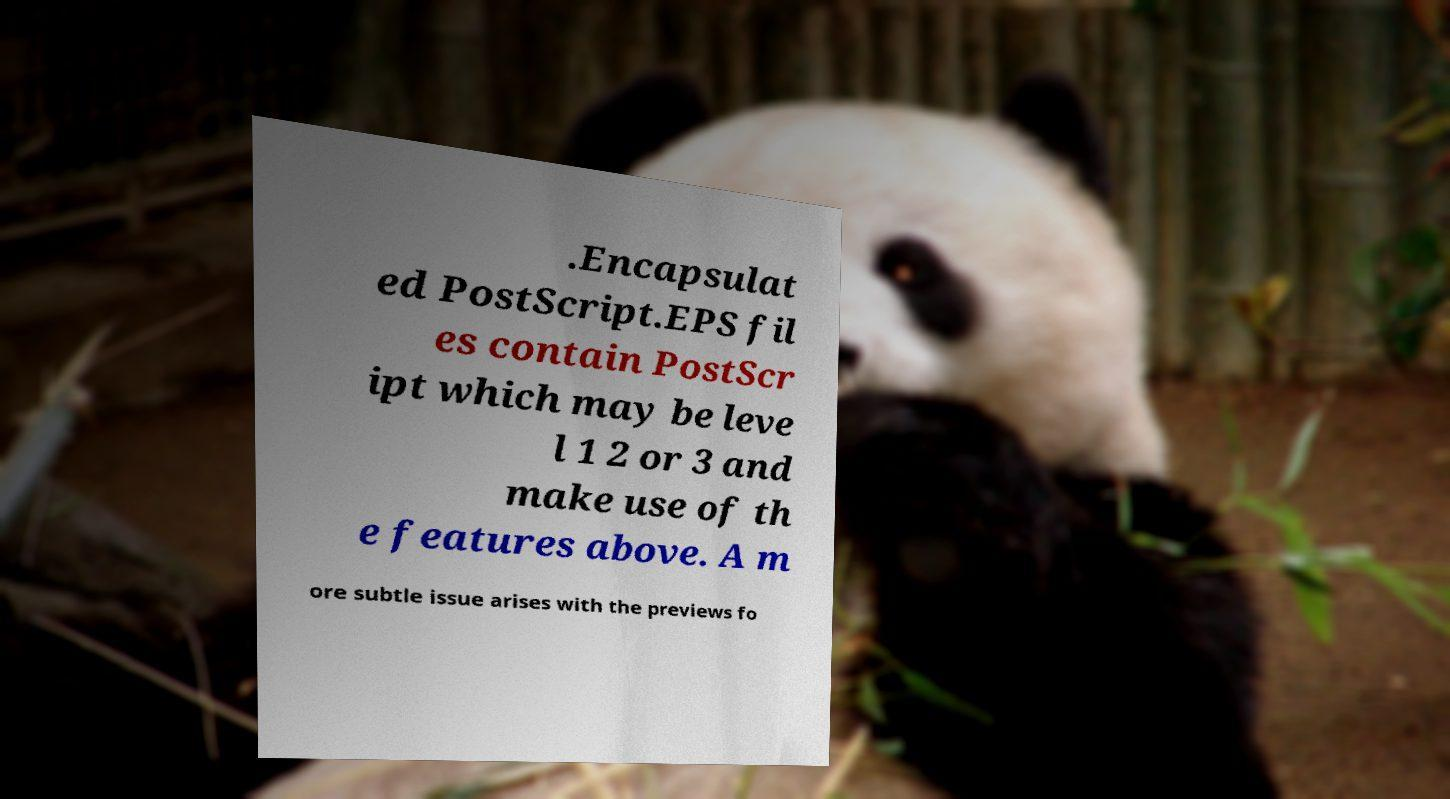Could you extract and type out the text from this image? .Encapsulat ed PostScript.EPS fil es contain PostScr ipt which may be leve l 1 2 or 3 and make use of th e features above. A m ore subtle issue arises with the previews fo 